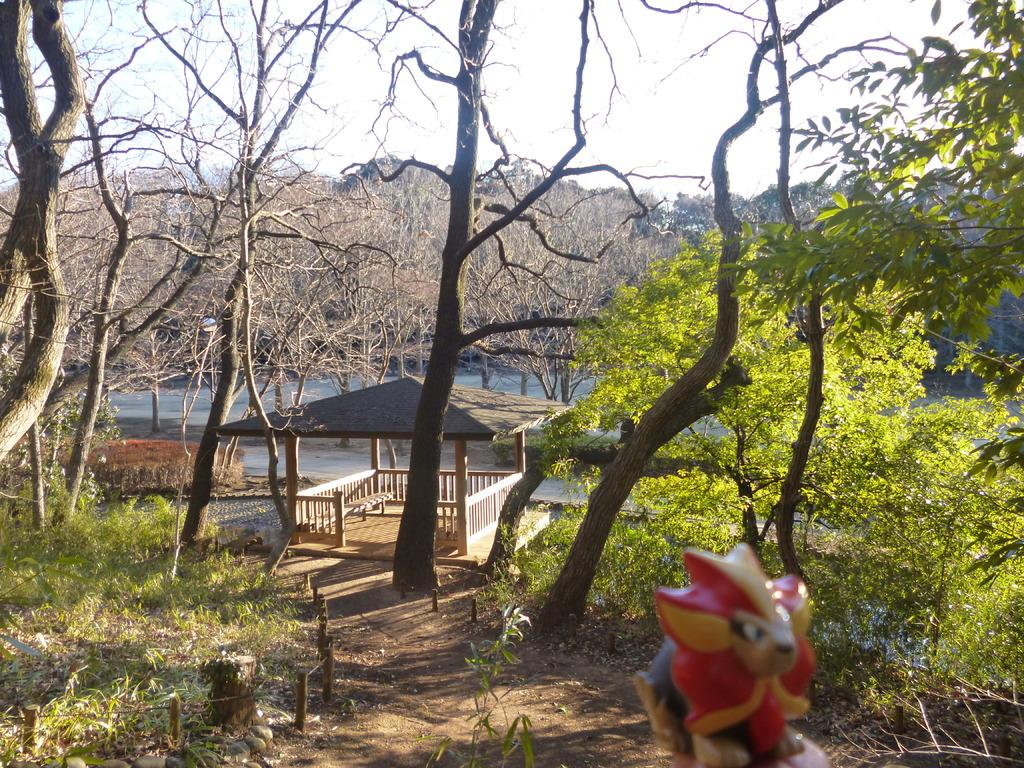What object can be found in the bottom right side of the image? There is a toy in the bottom right side of the image. What type of surface is visible in the image? The ground is visible in the image. What kind of vegetation is present on the ground? Grass is present on the ground. What other natural elements can be seen in the image? There are trees and plants in the image. What man-made structures are visible in the image? Poles, a tree trunk, a shed, and possibly the toy are man-made structures visible in the image. What part of the natural environment is visible in the image? The sky is visible in the image. What type of game is being played in the image? There is no game being played in the image; it features a toy, trees, plants, and other natural and man-made elements. Can you hear the people in the image laughing? There is no audio information in the image, so we cannot determine if people are laughing or not. 